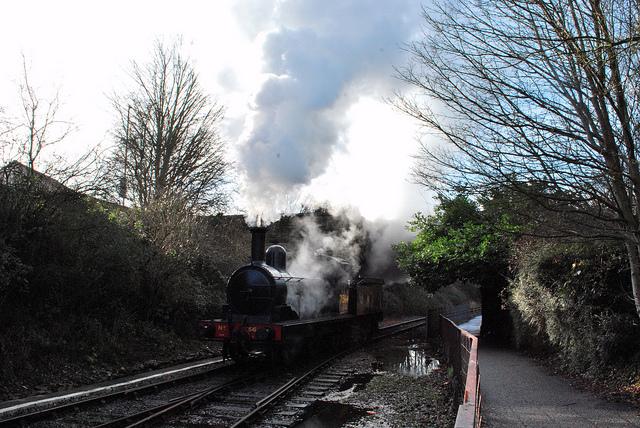Where is the train?
Keep it brief. On tracks. Was this photo taken at night?
Be succinct. No. Is this a steam engine?
Concise answer only. Yes. 